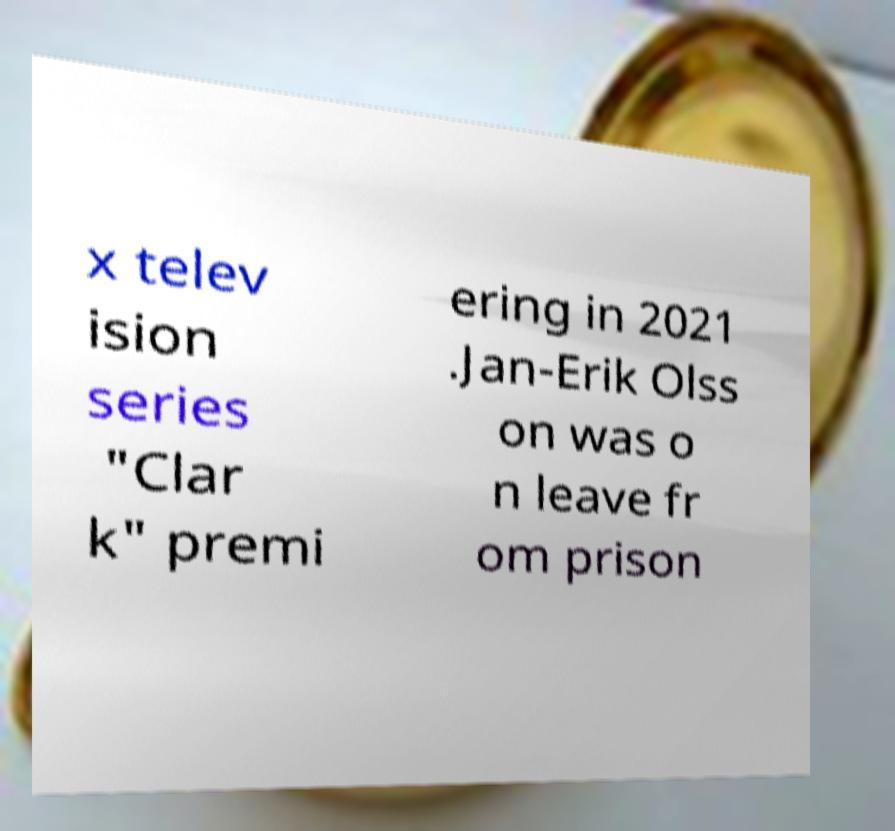There's text embedded in this image that I need extracted. Can you transcribe it verbatim? x telev ision series "Clar k" premi ering in 2021 .Jan-Erik Olss on was o n leave fr om prison 